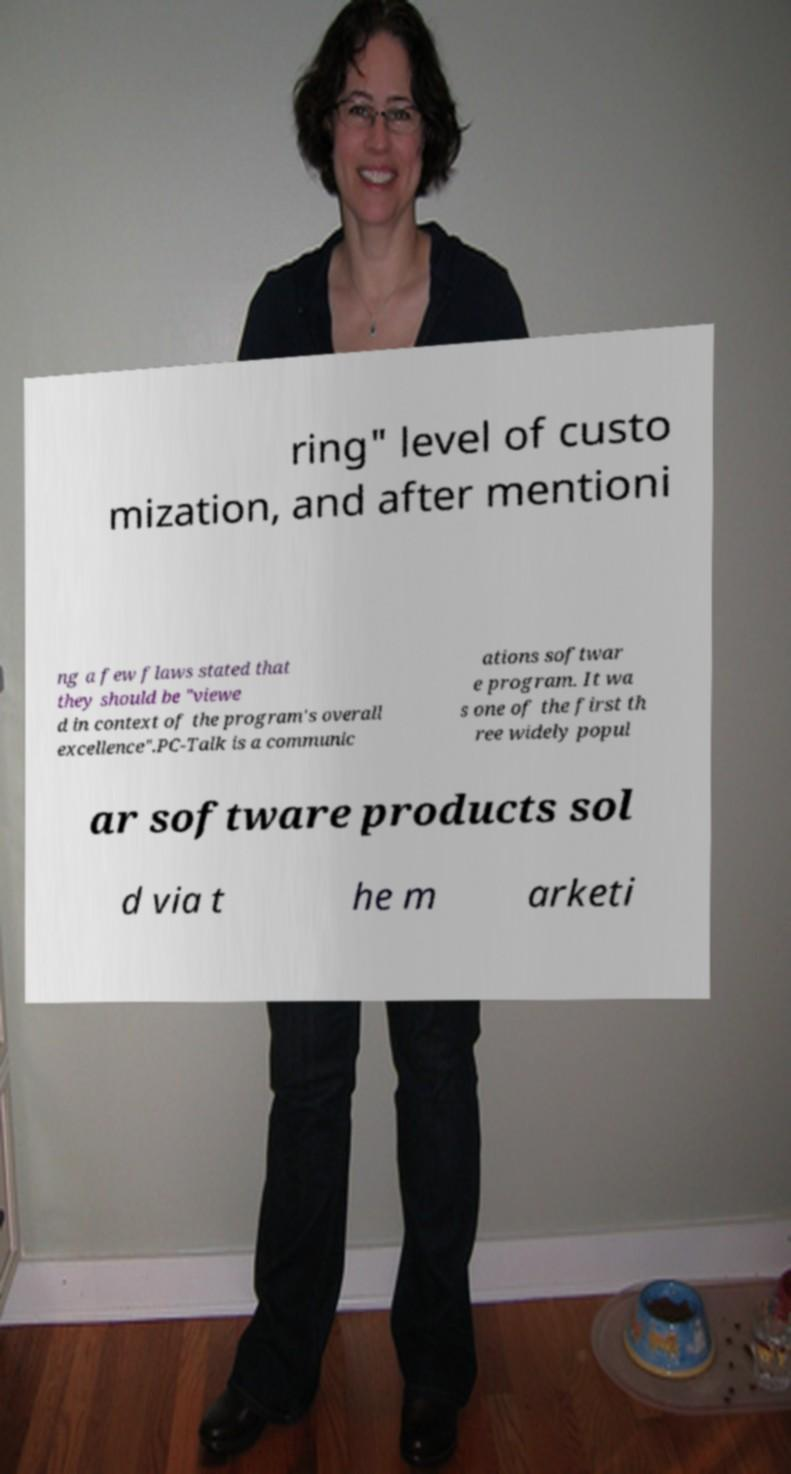For documentation purposes, I need the text within this image transcribed. Could you provide that? ring" level of custo mization, and after mentioni ng a few flaws stated that they should be "viewe d in context of the program's overall excellence".PC-Talk is a communic ations softwar e program. It wa s one of the first th ree widely popul ar software products sol d via t he m arketi 